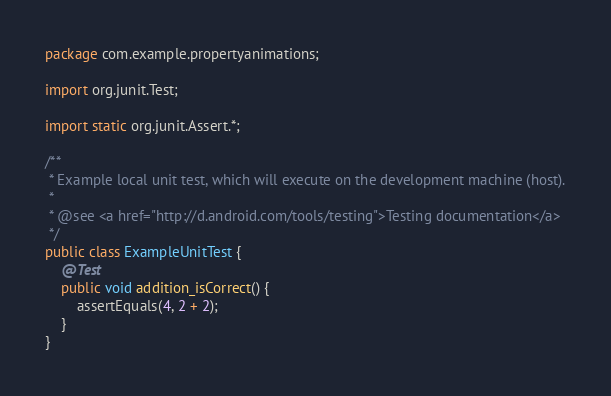Convert code to text. <code><loc_0><loc_0><loc_500><loc_500><_Java_>package com.example.propertyanimations;

import org.junit.Test;

import static org.junit.Assert.*;

/**
 * Example local unit test, which will execute on the development machine (host).
 *
 * @see <a href="http://d.android.com/tools/testing">Testing documentation</a>
 */
public class ExampleUnitTest {
    @Test
    public void addition_isCorrect() {
        assertEquals(4, 2 + 2);
    }
}</code> 